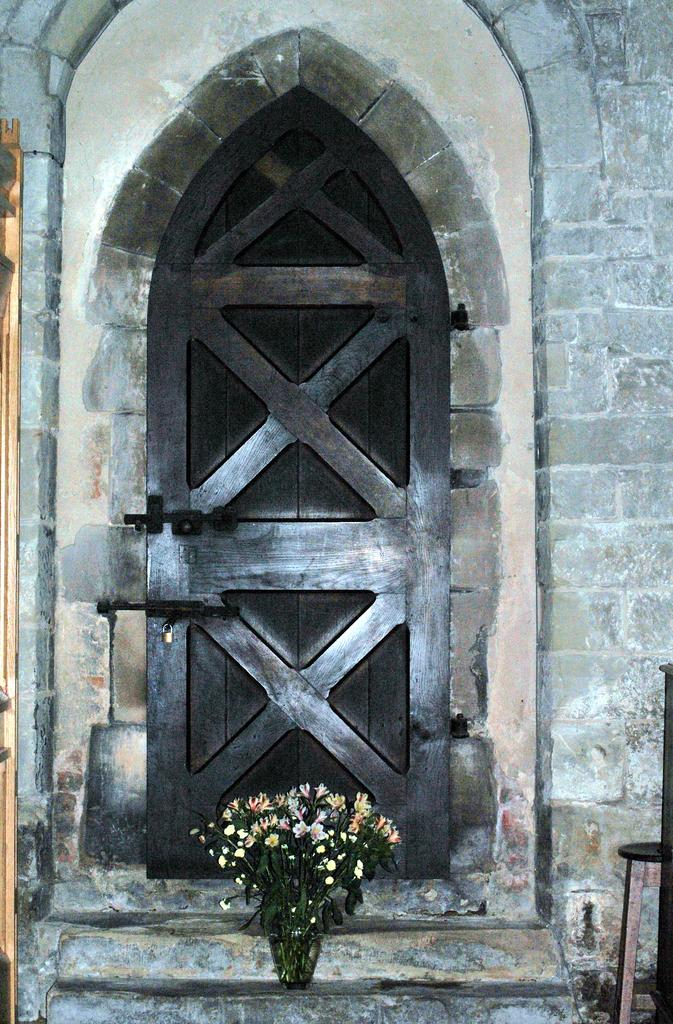What type of door is visible in the image? There is a wooden door in the image. What is placed in front of the door in the image? There is a flower bouquet in front of the door in the image. What song is the fireman singing while standing on the spot in the image? There is no fireman, song, or spot present in the image. 